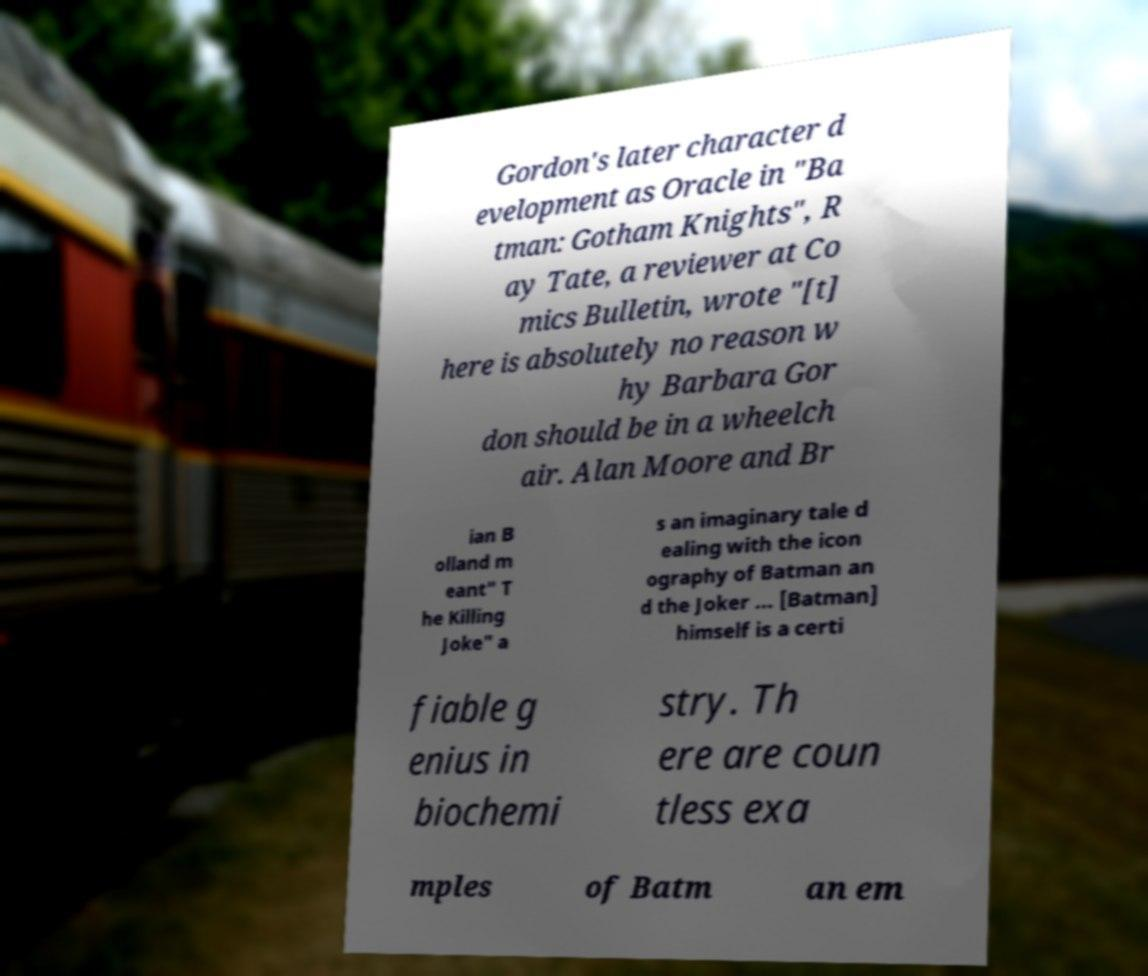Could you assist in decoding the text presented in this image and type it out clearly? Gordon's later character d evelopment as Oracle in "Ba tman: Gotham Knights", R ay Tate, a reviewer at Co mics Bulletin, wrote "[t] here is absolutely no reason w hy Barbara Gor don should be in a wheelch air. Alan Moore and Br ian B olland m eant" T he Killing Joke" a s an imaginary tale d ealing with the icon ography of Batman an d the Joker ... [Batman] himself is a certi fiable g enius in biochemi stry. Th ere are coun tless exa mples of Batm an em 